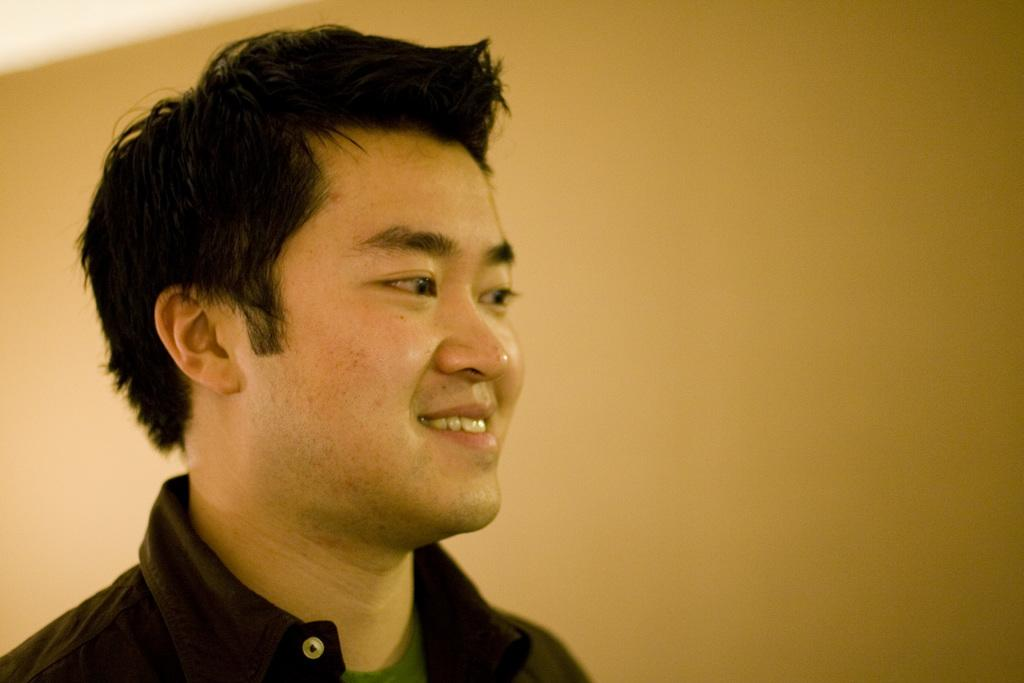Who or what is the main subject of the image? There is a person in the image. What is the person doing in the image? The person is smiling and looking towards the right. Can you describe the background of the image? The background of the image is blurred. What type of skirt is the person wearing in the image? There is no information about the person's clothing in the image, so it cannot be determined if they are wearing a skirt or not. 